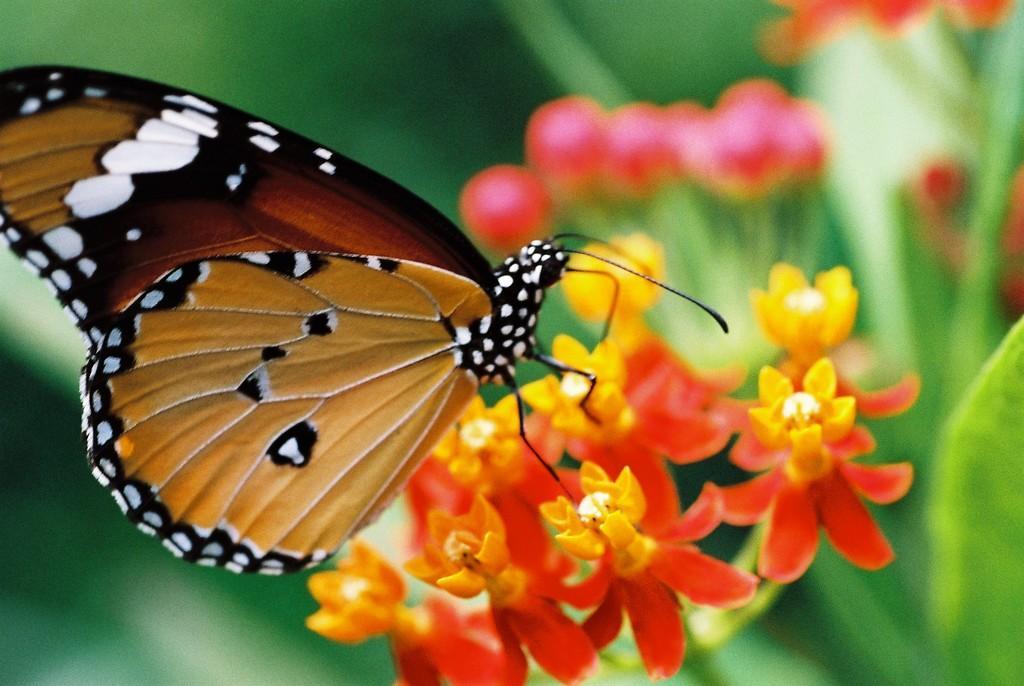In one or two sentences, can you explain what this image depicts? In this image we can see there is a butterfly on the flower. 